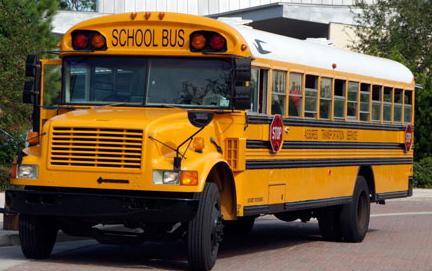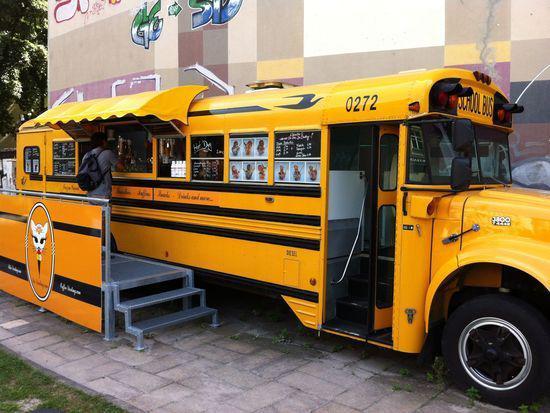The first image is the image on the left, the second image is the image on the right. Evaluate the accuracy of this statement regarding the images: "People stand outside the bus in the image on the right.". Is it true? Answer yes or no. No. The first image is the image on the left, the second image is the image on the right. Evaluate the accuracy of this statement regarding the images: "At least 2 people are standing on the ground next to the school bus.". Is it true? Answer yes or no. No. 